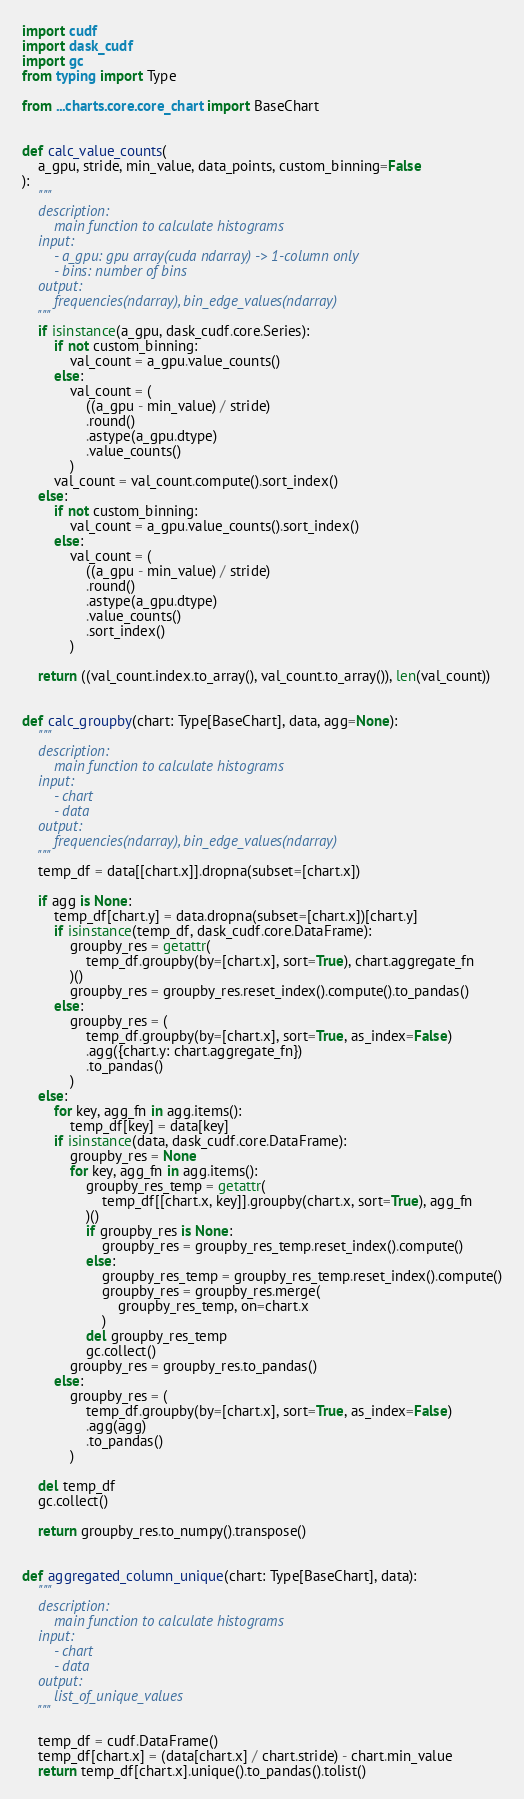<code> <loc_0><loc_0><loc_500><loc_500><_Python_>import cudf
import dask_cudf
import gc
from typing import Type

from ...charts.core.core_chart import BaseChart


def calc_value_counts(
    a_gpu, stride, min_value, data_points, custom_binning=False
):
    """
    description:
        main function to calculate histograms
    input:
        - a_gpu: gpu array(cuda ndarray) -> 1-column only
        - bins: number of bins
    output:
        frequencies(ndarray), bin_edge_values(ndarray)
    """
    if isinstance(a_gpu, dask_cudf.core.Series):
        if not custom_binning:
            val_count = a_gpu.value_counts()
        else:
            val_count = (
                ((a_gpu - min_value) / stride)
                .round()
                .astype(a_gpu.dtype)
                .value_counts()
            )
        val_count = val_count.compute().sort_index()
    else:
        if not custom_binning:
            val_count = a_gpu.value_counts().sort_index()
        else:
            val_count = (
                ((a_gpu - min_value) / stride)
                .round()
                .astype(a_gpu.dtype)
                .value_counts()
                .sort_index()
            )

    return ((val_count.index.to_array(), val_count.to_array()), len(val_count))


def calc_groupby(chart: Type[BaseChart], data, agg=None):
    """
    description:
        main function to calculate histograms
    input:
        - chart
        - data
    output:
        frequencies(ndarray), bin_edge_values(ndarray)
    """
    temp_df = data[[chart.x]].dropna(subset=[chart.x])

    if agg is None:
        temp_df[chart.y] = data.dropna(subset=[chart.x])[chart.y]
        if isinstance(temp_df, dask_cudf.core.DataFrame):
            groupby_res = getattr(
                temp_df.groupby(by=[chart.x], sort=True), chart.aggregate_fn
            )()
            groupby_res = groupby_res.reset_index().compute().to_pandas()
        else:
            groupby_res = (
                temp_df.groupby(by=[chart.x], sort=True, as_index=False)
                .agg({chart.y: chart.aggregate_fn})
                .to_pandas()
            )
    else:
        for key, agg_fn in agg.items():
            temp_df[key] = data[key]
        if isinstance(data, dask_cudf.core.DataFrame):
            groupby_res = None
            for key, agg_fn in agg.items():
                groupby_res_temp = getattr(
                    temp_df[[chart.x, key]].groupby(chart.x, sort=True), agg_fn
                )()
                if groupby_res is None:
                    groupby_res = groupby_res_temp.reset_index().compute()
                else:
                    groupby_res_temp = groupby_res_temp.reset_index().compute()
                    groupby_res = groupby_res.merge(
                        groupby_res_temp, on=chart.x
                    )
                del groupby_res_temp
                gc.collect()
            groupby_res = groupby_res.to_pandas()
        else:
            groupby_res = (
                temp_df.groupby(by=[chart.x], sort=True, as_index=False)
                .agg(agg)
                .to_pandas()
            )

    del temp_df
    gc.collect()

    return groupby_res.to_numpy().transpose()


def aggregated_column_unique(chart: Type[BaseChart], data):
    """
    description:
        main function to calculate histograms
    input:
        - chart
        - data
    output:
        list_of_unique_values
    """

    temp_df = cudf.DataFrame()
    temp_df[chart.x] = (data[chart.x] / chart.stride) - chart.min_value
    return temp_df[chart.x].unique().to_pandas().tolist()
</code> 